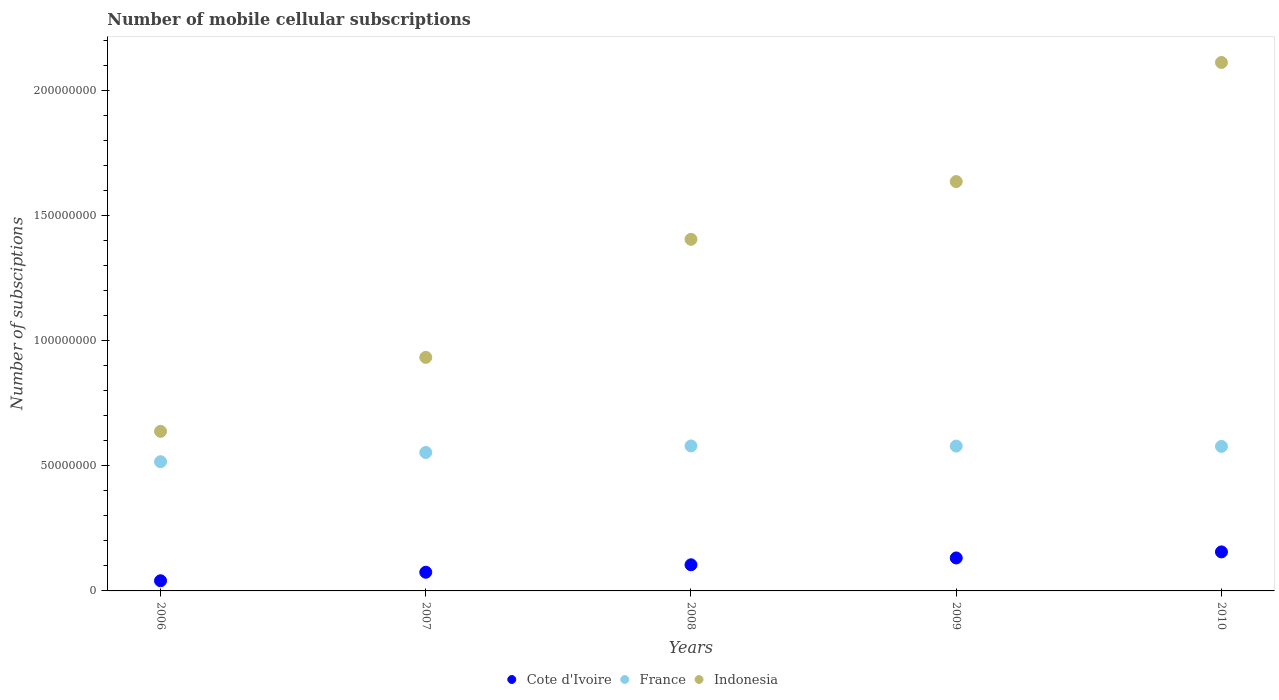How many different coloured dotlines are there?
Your response must be concise. 3. What is the number of mobile cellular subscriptions in Cote d'Ivoire in 2008?
Make the answer very short. 1.04e+07. Across all years, what is the maximum number of mobile cellular subscriptions in Cote d'Ivoire?
Keep it short and to the point. 1.56e+07. Across all years, what is the minimum number of mobile cellular subscriptions in France?
Make the answer very short. 5.17e+07. What is the total number of mobile cellular subscriptions in Indonesia in the graph?
Give a very brief answer. 6.73e+08. What is the difference between the number of mobile cellular subscriptions in Indonesia in 2007 and that in 2009?
Ensure brevity in your answer.  -7.03e+07. What is the difference between the number of mobile cellular subscriptions in Indonesia in 2006 and the number of mobile cellular subscriptions in France in 2008?
Your answer should be compact. 5.83e+06. What is the average number of mobile cellular subscriptions in Indonesia per year?
Provide a succinct answer. 1.35e+08. In the year 2010, what is the difference between the number of mobile cellular subscriptions in France and number of mobile cellular subscriptions in Indonesia?
Offer a terse response. -1.54e+08. What is the ratio of the number of mobile cellular subscriptions in Indonesia in 2008 to that in 2010?
Provide a short and direct response. 0.67. What is the difference between the highest and the second highest number of mobile cellular subscriptions in Indonesia?
Offer a terse response. 4.76e+07. What is the difference between the highest and the lowest number of mobile cellular subscriptions in Indonesia?
Make the answer very short. 1.47e+08. In how many years, is the number of mobile cellular subscriptions in Indonesia greater than the average number of mobile cellular subscriptions in Indonesia taken over all years?
Your response must be concise. 3. Is the sum of the number of mobile cellular subscriptions in France in 2006 and 2007 greater than the maximum number of mobile cellular subscriptions in Indonesia across all years?
Provide a succinct answer. No. How many years are there in the graph?
Offer a very short reply. 5. Where does the legend appear in the graph?
Provide a succinct answer. Bottom center. How many legend labels are there?
Your response must be concise. 3. What is the title of the graph?
Offer a very short reply. Number of mobile cellular subscriptions. What is the label or title of the X-axis?
Offer a terse response. Years. What is the label or title of the Y-axis?
Offer a very short reply. Number of subsciptions. What is the Number of subsciptions in Cote d'Ivoire in 2006?
Keep it short and to the point. 4.07e+06. What is the Number of subsciptions of France in 2006?
Offer a terse response. 5.17e+07. What is the Number of subsciptions in Indonesia in 2006?
Your response must be concise. 6.38e+07. What is the Number of subsciptions in Cote d'Ivoire in 2007?
Your answer should be very brief. 7.47e+06. What is the Number of subsciptions of France in 2007?
Ensure brevity in your answer.  5.54e+07. What is the Number of subsciptions of Indonesia in 2007?
Keep it short and to the point. 9.34e+07. What is the Number of subsciptions in Cote d'Ivoire in 2008?
Your response must be concise. 1.04e+07. What is the Number of subsciptions in France in 2008?
Ensure brevity in your answer.  5.80e+07. What is the Number of subsciptions in Indonesia in 2008?
Give a very brief answer. 1.41e+08. What is the Number of subsciptions in Cote d'Ivoire in 2009?
Provide a short and direct response. 1.32e+07. What is the Number of subsciptions of France in 2009?
Offer a terse response. 5.79e+07. What is the Number of subsciptions of Indonesia in 2009?
Offer a very short reply. 1.64e+08. What is the Number of subsciptions of Cote d'Ivoire in 2010?
Offer a terse response. 1.56e+07. What is the Number of subsciptions of France in 2010?
Keep it short and to the point. 5.78e+07. What is the Number of subsciptions of Indonesia in 2010?
Your answer should be compact. 2.11e+08. Across all years, what is the maximum Number of subsciptions in Cote d'Ivoire?
Give a very brief answer. 1.56e+07. Across all years, what is the maximum Number of subsciptions of France?
Your response must be concise. 5.80e+07. Across all years, what is the maximum Number of subsciptions in Indonesia?
Your answer should be compact. 2.11e+08. Across all years, what is the minimum Number of subsciptions in Cote d'Ivoire?
Your answer should be compact. 4.07e+06. Across all years, what is the minimum Number of subsciptions in France?
Make the answer very short. 5.17e+07. Across all years, what is the minimum Number of subsciptions of Indonesia?
Offer a terse response. 6.38e+07. What is the total Number of subsciptions in Cote d'Ivoire in the graph?
Ensure brevity in your answer.  5.08e+07. What is the total Number of subsciptions in France in the graph?
Offer a terse response. 2.81e+08. What is the total Number of subsciptions of Indonesia in the graph?
Make the answer very short. 6.73e+08. What is the difference between the Number of subsciptions of Cote d'Ivoire in 2006 and that in 2007?
Provide a succinct answer. -3.40e+06. What is the difference between the Number of subsciptions of France in 2006 and that in 2007?
Keep it short and to the point. -3.70e+06. What is the difference between the Number of subsciptions in Indonesia in 2006 and that in 2007?
Make the answer very short. -2.96e+07. What is the difference between the Number of subsciptions in Cote d'Ivoire in 2006 and that in 2008?
Your response must be concise. -6.38e+06. What is the difference between the Number of subsciptions in France in 2006 and that in 2008?
Ensure brevity in your answer.  -6.31e+06. What is the difference between the Number of subsciptions of Indonesia in 2006 and that in 2008?
Your answer should be very brief. -7.68e+07. What is the difference between the Number of subsciptions in Cote d'Ivoire in 2006 and that in 2009?
Provide a short and direct response. -9.12e+06. What is the difference between the Number of subsciptions of France in 2006 and that in 2009?
Offer a terse response. -6.26e+06. What is the difference between the Number of subsciptions in Indonesia in 2006 and that in 2009?
Keep it short and to the point. -9.99e+07. What is the difference between the Number of subsciptions of Cote d'Ivoire in 2006 and that in 2010?
Make the answer very short. -1.15e+07. What is the difference between the Number of subsciptions in France in 2006 and that in 2010?
Ensure brevity in your answer.  -6.12e+06. What is the difference between the Number of subsciptions in Indonesia in 2006 and that in 2010?
Your answer should be very brief. -1.47e+08. What is the difference between the Number of subsciptions in Cote d'Ivoire in 2007 and that in 2008?
Make the answer very short. -2.98e+06. What is the difference between the Number of subsciptions in France in 2007 and that in 2008?
Provide a succinct answer. -2.61e+06. What is the difference between the Number of subsciptions in Indonesia in 2007 and that in 2008?
Offer a terse response. -4.72e+07. What is the difference between the Number of subsciptions in Cote d'Ivoire in 2007 and that in 2009?
Give a very brief answer. -5.72e+06. What is the difference between the Number of subsciptions of France in 2007 and that in 2009?
Your response must be concise. -2.56e+06. What is the difference between the Number of subsciptions in Indonesia in 2007 and that in 2009?
Provide a short and direct response. -7.03e+07. What is the difference between the Number of subsciptions in Cote d'Ivoire in 2007 and that in 2010?
Keep it short and to the point. -8.13e+06. What is the difference between the Number of subsciptions of France in 2007 and that in 2010?
Your answer should be very brief. -2.43e+06. What is the difference between the Number of subsciptions of Indonesia in 2007 and that in 2010?
Keep it short and to the point. -1.18e+08. What is the difference between the Number of subsciptions in Cote d'Ivoire in 2008 and that in 2009?
Offer a very short reply. -2.74e+06. What is the difference between the Number of subsciptions of France in 2008 and that in 2009?
Ensure brevity in your answer.  5.40e+04. What is the difference between the Number of subsciptions in Indonesia in 2008 and that in 2009?
Provide a succinct answer. -2.31e+07. What is the difference between the Number of subsciptions in Cote d'Ivoire in 2008 and that in 2010?
Keep it short and to the point. -5.15e+06. What is the difference between the Number of subsciptions of France in 2008 and that in 2010?
Ensure brevity in your answer.  1.87e+05. What is the difference between the Number of subsciptions of Indonesia in 2008 and that in 2010?
Keep it short and to the point. -7.07e+07. What is the difference between the Number of subsciptions in Cote d'Ivoire in 2009 and that in 2010?
Keep it short and to the point. -2.41e+06. What is the difference between the Number of subsciptions of France in 2009 and that in 2010?
Provide a short and direct response. 1.33e+05. What is the difference between the Number of subsciptions in Indonesia in 2009 and that in 2010?
Your response must be concise. -4.76e+07. What is the difference between the Number of subsciptions in Cote d'Ivoire in 2006 and the Number of subsciptions in France in 2007?
Make the answer very short. -5.13e+07. What is the difference between the Number of subsciptions of Cote d'Ivoire in 2006 and the Number of subsciptions of Indonesia in 2007?
Offer a very short reply. -8.93e+07. What is the difference between the Number of subsciptions of France in 2006 and the Number of subsciptions of Indonesia in 2007?
Your response must be concise. -4.17e+07. What is the difference between the Number of subsciptions in Cote d'Ivoire in 2006 and the Number of subsciptions in France in 2008?
Your answer should be very brief. -5.39e+07. What is the difference between the Number of subsciptions of Cote d'Ivoire in 2006 and the Number of subsciptions of Indonesia in 2008?
Provide a succinct answer. -1.37e+08. What is the difference between the Number of subsciptions of France in 2006 and the Number of subsciptions of Indonesia in 2008?
Your response must be concise. -8.89e+07. What is the difference between the Number of subsciptions of Cote d'Ivoire in 2006 and the Number of subsciptions of France in 2009?
Give a very brief answer. -5.39e+07. What is the difference between the Number of subsciptions of Cote d'Ivoire in 2006 and the Number of subsciptions of Indonesia in 2009?
Your response must be concise. -1.60e+08. What is the difference between the Number of subsciptions in France in 2006 and the Number of subsciptions in Indonesia in 2009?
Provide a short and direct response. -1.12e+08. What is the difference between the Number of subsciptions of Cote d'Ivoire in 2006 and the Number of subsciptions of France in 2010?
Your response must be concise. -5.37e+07. What is the difference between the Number of subsciptions in Cote d'Ivoire in 2006 and the Number of subsciptions in Indonesia in 2010?
Your answer should be very brief. -2.07e+08. What is the difference between the Number of subsciptions in France in 2006 and the Number of subsciptions in Indonesia in 2010?
Your answer should be very brief. -1.60e+08. What is the difference between the Number of subsciptions of Cote d'Ivoire in 2007 and the Number of subsciptions of France in 2008?
Keep it short and to the point. -5.05e+07. What is the difference between the Number of subsciptions in Cote d'Ivoire in 2007 and the Number of subsciptions in Indonesia in 2008?
Offer a terse response. -1.33e+08. What is the difference between the Number of subsciptions in France in 2007 and the Number of subsciptions in Indonesia in 2008?
Make the answer very short. -8.52e+07. What is the difference between the Number of subsciptions in Cote d'Ivoire in 2007 and the Number of subsciptions in France in 2009?
Offer a terse response. -5.05e+07. What is the difference between the Number of subsciptions of Cote d'Ivoire in 2007 and the Number of subsciptions of Indonesia in 2009?
Offer a terse response. -1.56e+08. What is the difference between the Number of subsciptions of France in 2007 and the Number of subsciptions of Indonesia in 2009?
Your answer should be compact. -1.08e+08. What is the difference between the Number of subsciptions in Cote d'Ivoire in 2007 and the Number of subsciptions in France in 2010?
Make the answer very short. -5.03e+07. What is the difference between the Number of subsciptions of Cote d'Ivoire in 2007 and the Number of subsciptions of Indonesia in 2010?
Give a very brief answer. -2.04e+08. What is the difference between the Number of subsciptions in France in 2007 and the Number of subsciptions in Indonesia in 2010?
Your answer should be compact. -1.56e+08. What is the difference between the Number of subsciptions in Cote d'Ivoire in 2008 and the Number of subsciptions in France in 2009?
Give a very brief answer. -4.75e+07. What is the difference between the Number of subsciptions of Cote d'Ivoire in 2008 and the Number of subsciptions of Indonesia in 2009?
Your response must be concise. -1.53e+08. What is the difference between the Number of subsciptions in France in 2008 and the Number of subsciptions in Indonesia in 2009?
Keep it short and to the point. -1.06e+08. What is the difference between the Number of subsciptions of Cote d'Ivoire in 2008 and the Number of subsciptions of France in 2010?
Your answer should be compact. -4.73e+07. What is the difference between the Number of subsciptions of Cote d'Ivoire in 2008 and the Number of subsciptions of Indonesia in 2010?
Give a very brief answer. -2.01e+08. What is the difference between the Number of subsciptions of France in 2008 and the Number of subsciptions of Indonesia in 2010?
Keep it short and to the point. -1.53e+08. What is the difference between the Number of subsciptions of Cote d'Ivoire in 2009 and the Number of subsciptions of France in 2010?
Offer a terse response. -4.46e+07. What is the difference between the Number of subsciptions in Cote d'Ivoire in 2009 and the Number of subsciptions in Indonesia in 2010?
Provide a short and direct response. -1.98e+08. What is the difference between the Number of subsciptions of France in 2009 and the Number of subsciptions of Indonesia in 2010?
Your response must be concise. -1.53e+08. What is the average Number of subsciptions in Cote d'Ivoire per year?
Your answer should be very brief. 1.02e+07. What is the average Number of subsciptions of France per year?
Provide a short and direct response. 5.61e+07. What is the average Number of subsciptions in Indonesia per year?
Keep it short and to the point. 1.35e+08. In the year 2006, what is the difference between the Number of subsciptions in Cote d'Ivoire and Number of subsciptions in France?
Give a very brief answer. -4.76e+07. In the year 2006, what is the difference between the Number of subsciptions of Cote d'Ivoire and Number of subsciptions of Indonesia?
Make the answer very short. -5.97e+07. In the year 2006, what is the difference between the Number of subsciptions of France and Number of subsciptions of Indonesia?
Your response must be concise. -1.21e+07. In the year 2007, what is the difference between the Number of subsciptions in Cote d'Ivoire and Number of subsciptions in France?
Make the answer very short. -4.79e+07. In the year 2007, what is the difference between the Number of subsciptions of Cote d'Ivoire and Number of subsciptions of Indonesia?
Make the answer very short. -8.59e+07. In the year 2007, what is the difference between the Number of subsciptions in France and Number of subsciptions in Indonesia?
Ensure brevity in your answer.  -3.80e+07. In the year 2008, what is the difference between the Number of subsciptions in Cote d'Ivoire and Number of subsciptions in France?
Provide a succinct answer. -4.75e+07. In the year 2008, what is the difference between the Number of subsciptions in Cote d'Ivoire and Number of subsciptions in Indonesia?
Offer a terse response. -1.30e+08. In the year 2008, what is the difference between the Number of subsciptions of France and Number of subsciptions of Indonesia?
Provide a succinct answer. -8.26e+07. In the year 2009, what is the difference between the Number of subsciptions of Cote d'Ivoire and Number of subsciptions of France?
Keep it short and to the point. -4.47e+07. In the year 2009, what is the difference between the Number of subsciptions in Cote d'Ivoire and Number of subsciptions in Indonesia?
Your answer should be very brief. -1.50e+08. In the year 2009, what is the difference between the Number of subsciptions in France and Number of subsciptions in Indonesia?
Provide a succinct answer. -1.06e+08. In the year 2010, what is the difference between the Number of subsciptions in Cote d'Ivoire and Number of subsciptions in France?
Keep it short and to the point. -4.22e+07. In the year 2010, what is the difference between the Number of subsciptions in Cote d'Ivoire and Number of subsciptions in Indonesia?
Provide a short and direct response. -1.96e+08. In the year 2010, what is the difference between the Number of subsciptions of France and Number of subsciptions of Indonesia?
Offer a terse response. -1.54e+08. What is the ratio of the Number of subsciptions of Cote d'Ivoire in 2006 to that in 2007?
Offer a terse response. 0.54. What is the ratio of the Number of subsciptions in France in 2006 to that in 2007?
Provide a succinct answer. 0.93. What is the ratio of the Number of subsciptions in Indonesia in 2006 to that in 2007?
Your answer should be compact. 0.68. What is the ratio of the Number of subsciptions in Cote d'Ivoire in 2006 to that in 2008?
Offer a terse response. 0.39. What is the ratio of the Number of subsciptions in France in 2006 to that in 2008?
Your response must be concise. 0.89. What is the ratio of the Number of subsciptions in Indonesia in 2006 to that in 2008?
Provide a short and direct response. 0.45. What is the ratio of the Number of subsciptions in Cote d'Ivoire in 2006 to that in 2009?
Your answer should be compact. 0.31. What is the ratio of the Number of subsciptions in France in 2006 to that in 2009?
Give a very brief answer. 0.89. What is the ratio of the Number of subsciptions of Indonesia in 2006 to that in 2009?
Your answer should be compact. 0.39. What is the ratio of the Number of subsciptions in Cote d'Ivoire in 2006 to that in 2010?
Make the answer very short. 0.26. What is the ratio of the Number of subsciptions of France in 2006 to that in 2010?
Your response must be concise. 0.89. What is the ratio of the Number of subsciptions in Indonesia in 2006 to that in 2010?
Your answer should be very brief. 0.3. What is the ratio of the Number of subsciptions of Cote d'Ivoire in 2007 to that in 2008?
Provide a short and direct response. 0.71. What is the ratio of the Number of subsciptions in France in 2007 to that in 2008?
Offer a very short reply. 0.95. What is the ratio of the Number of subsciptions of Indonesia in 2007 to that in 2008?
Provide a short and direct response. 0.66. What is the ratio of the Number of subsciptions in Cote d'Ivoire in 2007 to that in 2009?
Keep it short and to the point. 0.57. What is the ratio of the Number of subsciptions in France in 2007 to that in 2009?
Your answer should be compact. 0.96. What is the ratio of the Number of subsciptions of Indonesia in 2007 to that in 2009?
Offer a terse response. 0.57. What is the ratio of the Number of subsciptions in Cote d'Ivoire in 2007 to that in 2010?
Give a very brief answer. 0.48. What is the ratio of the Number of subsciptions of France in 2007 to that in 2010?
Give a very brief answer. 0.96. What is the ratio of the Number of subsciptions in Indonesia in 2007 to that in 2010?
Your answer should be very brief. 0.44. What is the ratio of the Number of subsciptions in Cote d'Ivoire in 2008 to that in 2009?
Offer a very short reply. 0.79. What is the ratio of the Number of subsciptions of France in 2008 to that in 2009?
Your response must be concise. 1. What is the ratio of the Number of subsciptions of Indonesia in 2008 to that in 2009?
Make the answer very short. 0.86. What is the ratio of the Number of subsciptions in Cote d'Ivoire in 2008 to that in 2010?
Offer a terse response. 0.67. What is the ratio of the Number of subsciptions in France in 2008 to that in 2010?
Your answer should be very brief. 1. What is the ratio of the Number of subsciptions of Indonesia in 2008 to that in 2010?
Offer a very short reply. 0.67. What is the ratio of the Number of subsciptions of Cote d'Ivoire in 2009 to that in 2010?
Offer a very short reply. 0.85. What is the ratio of the Number of subsciptions of Indonesia in 2009 to that in 2010?
Your answer should be compact. 0.77. What is the difference between the highest and the second highest Number of subsciptions in Cote d'Ivoire?
Your answer should be compact. 2.41e+06. What is the difference between the highest and the second highest Number of subsciptions of France?
Give a very brief answer. 5.40e+04. What is the difference between the highest and the second highest Number of subsciptions of Indonesia?
Your answer should be very brief. 4.76e+07. What is the difference between the highest and the lowest Number of subsciptions of Cote d'Ivoire?
Keep it short and to the point. 1.15e+07. What is the difference between the highest and the lowest Number of subsciptions in France?
Ensure brevity in your answer.  6.31e+06. What is the difference between the highest and the lowest Number of subsciptions of Indonesia?
Your response must be concise. 1.47e+08. 